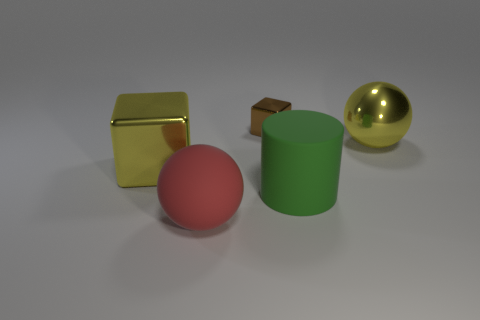What number of things are either tiny green spheres or large shiny things?
Keep it short and to the point. 2. What is the shape of the brown thing that is the same material as the yellow block?
Your answer should be very brief. Cube. How many big things are cubes or purple rubber objects?
Your answer should be compact. 1. What number of other objects are the same color as the cylinder?
Make the answer very short. 0. There is a shiny cube behind the big metallic object that is right of the big green cylinder; what number of large metallic cubes are behind it?
Offer a terse response. 0. There is a yellow object that is on the right side of the rubber cylinder; is it the same size as the tiny cube?
Your response must be concise. No. Is the number of big green matte cylinders that are on the left side of the tiny brown cube less than the number of large objects behind the cylinder?
Provide a short and direct response. Yes. Does the tiny metallic cube have the same color as the big cube?
Provide a short and direct response. No. Is the number of large matte things behind the metallic sphere less than the number of matte cylinders?
Offer a very short reply. Yes. What material is the large object that is the same color as the large metal block?
Ensure brevity in your answer.  Metal. 